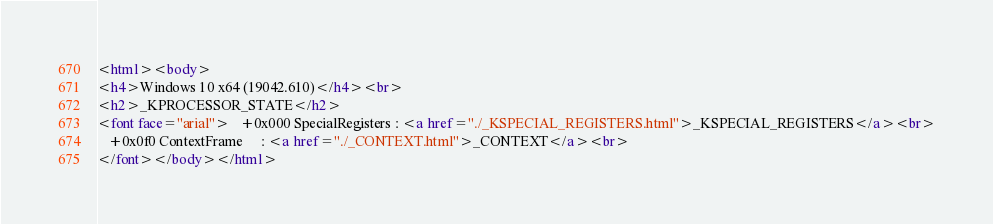<code> <loc_0><loc_0><loc_500><loc_500><_HTML_><html><body>
<h4>Windows 10 x64 (19042.610)</h4><br>
<h2>_KPROCESSOR_STATE</h2>
<font face="arial">   +0x000 SpecialRegisters : <a href="./_KSPECIAL_REGISTERS.html">_KSPECIAL_REGISTERS</a><br>
   +0x0f0 ContextFrame     : <a href="./_CONTEXT.html">_CONTEXT</a><br>
</font></body></html></code> 